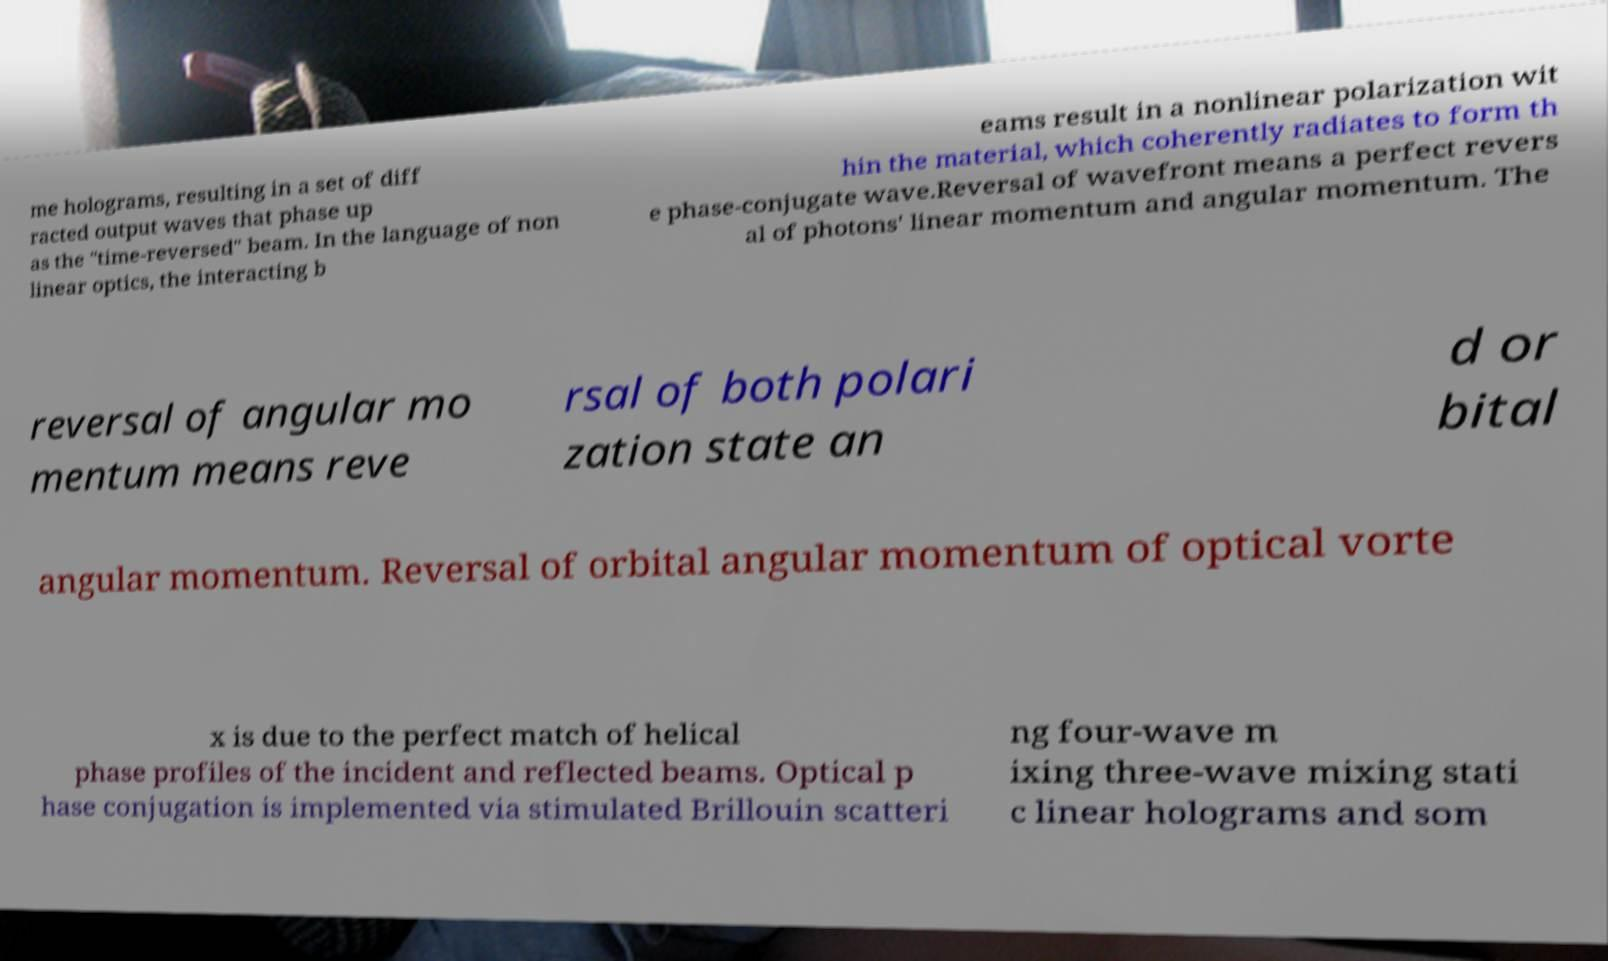For documentation purposes, I need the text within this image transcribed. Could you provide that? me holograms, resulting in a set of diff racted output waves that phase up as the "time-reversed" beam. In the language of non linear optics, the interacting b eams result in a nonlinear polarization wit hin the material, which coherently radiates to form th e phase-conjugate wave.Reversal of wavefront means a perfect revers al of photons' linear momentum and angular momentum. The reversal of angular mo mentum means reve rsal of both polari zation state an d or bital angular momentum. Reversal of orbital angular momentum of optical vorte x is due to the perfect match of helical phase profiles of the incident and reflected beams. Optical p hase conjugation is implemented via stimulated Brillouin scatteri ng four-wave m ixing three-wave mixing stati c linear holograms and som 